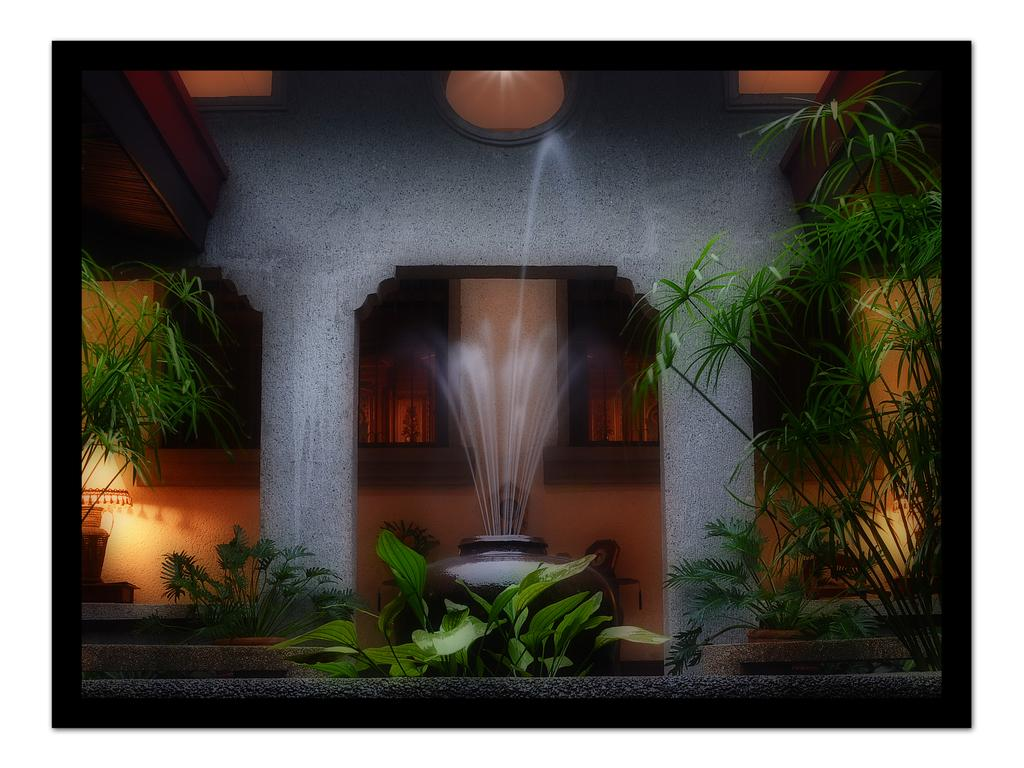What is the main feature in the image? There is a fountain in the image. Where is the fountain located in relation to the building? The fountain is in front of a building. What else can be seen around the fountain? There are plants around the fountain. What type of juice is being served in the fountain in the image? There is no juice being served in the fountain in the image; it is a water fountain. What arithmetic problem is being solved by the plants around the fountain? The plants around the fountain are not solving any arithmetic problems; they are simply plants. 